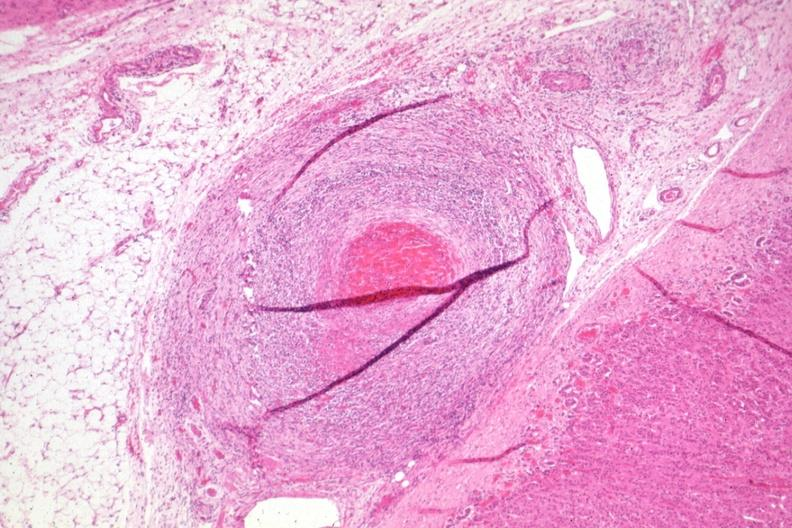does this image show healing lesion in medium size artery just outside adrenal capsule section has folds?
Answer the question using a single word or phrase. Yes 